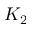Convert formula to latex. <formula><loc_0><loc_0><loc_500><loc_500>K _ { 2 }</formula> 